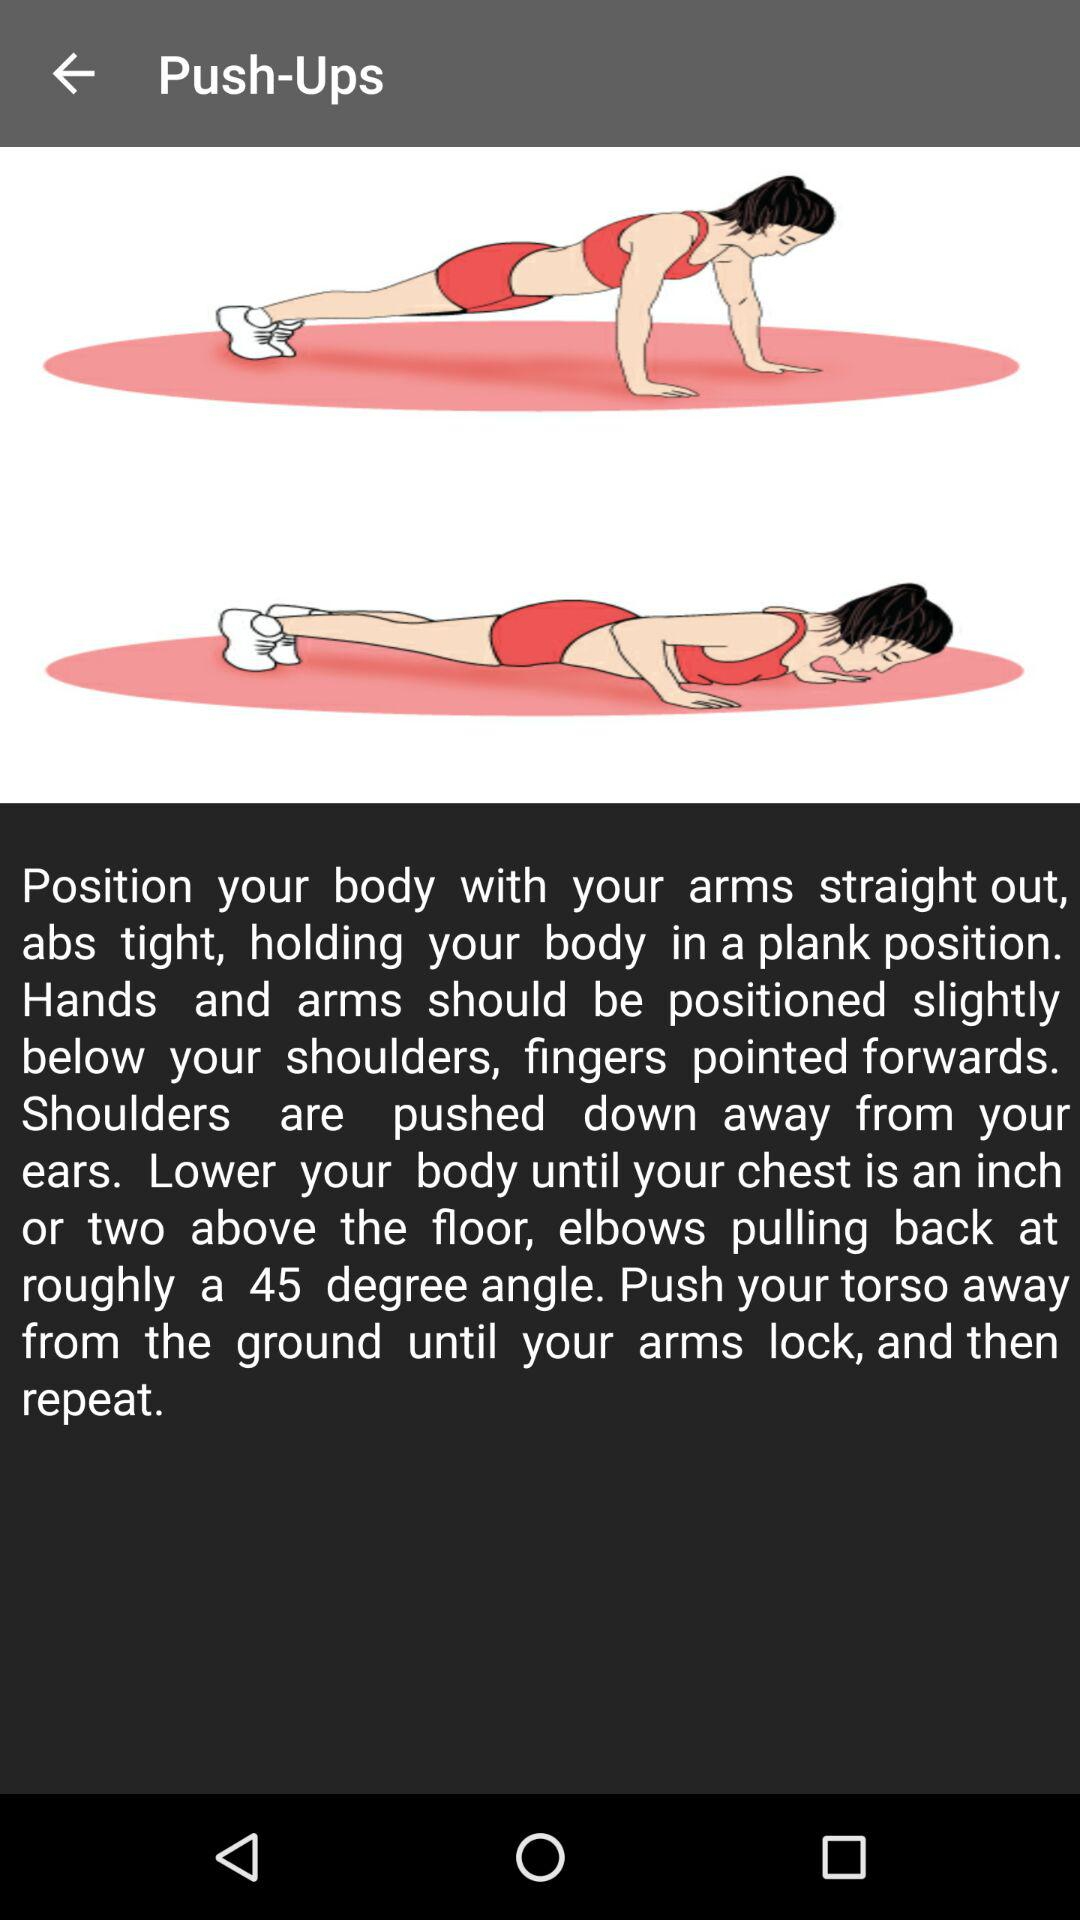What is the exercise? The exercise is push-ups. 